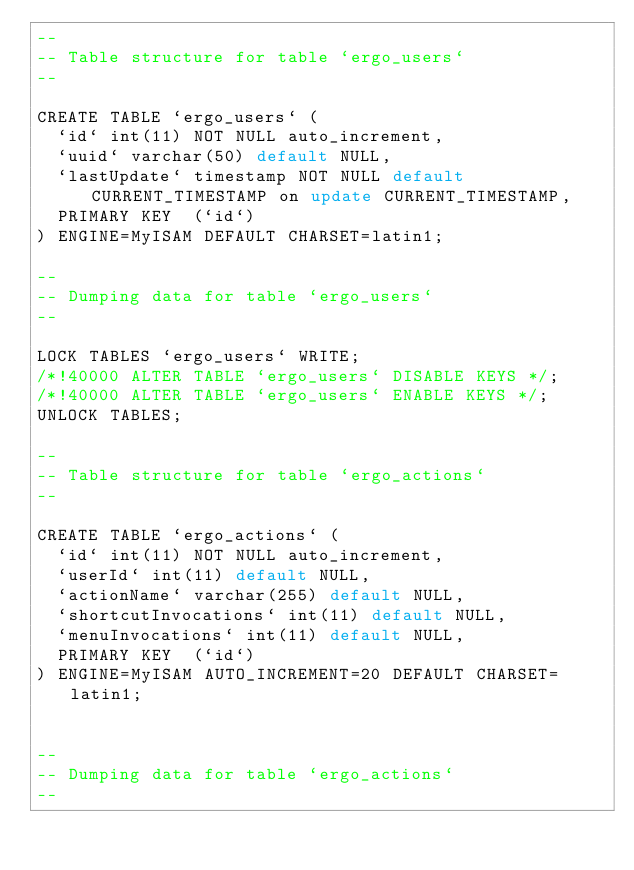Convert code to text. <code><loc_0><loc_0><loc_500><loc_500><_SQL_>--
-- Table structure for table `ergo_users`
--

CREATE TABLE `ergo_users` (
  `id` int(11) NOT NULL auto_increment,
  `uuid` varchar(50) default NULL,
  `lastUpdate` timestamp NOT NULL default CURRENT_TIMESTAMP on update CURRENT_TIMESTAMP,
  PRIMARY KEY  (`id`)
) ENGINE=MyISAM DEFAULT CHARSET=latin1;

--
-- Dumping data for table `ergo_users`
--

LOCK TABLES `ergo_users` WRITE;
/*!40000 ALTER TABLE `ergo_users` DISABLE KEYS */;
/*!40000 ALTER TABLE `ergo_users` ENABLE KEYS */;
UNLOCK TABLES;

--
-- Table structure for table `ergo_actions`
--

CREATE TABLE `ergo_actions` (
  `id` int(11) NOT NULL auto_increment,
  `userId` int(11) default NULL,
  `actionName` varchar(255) default NULL,
  `shortcutInvocations` int(11) default NULL,
  `menuInvocations` int(11) default NULL,
  PRIMARY KEY  (`id`)
) ENGINE=MyISAM AUTO_INCREMENT=20 DEFAULT CHARSET=latin1;


--
-- Dumping data for table `ergo_actions`
--</code> 